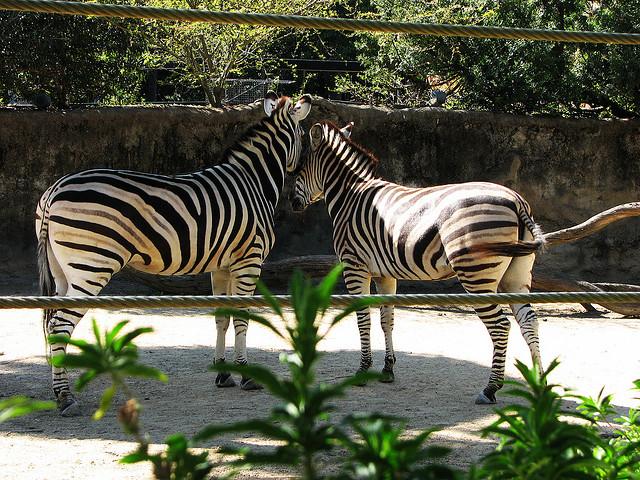Are the zebras male?
Answer briefly. No. Which zebra is taller?
Write a very short answer. One on left. What are the Zebras interested in?
Be succinct. Each other. Do these animals have tails?
Write a very short answer. Yes. 